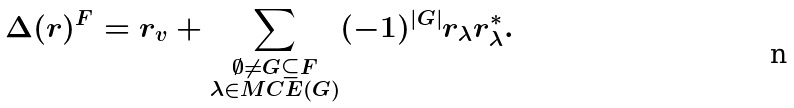<formula> <loc_0><loc_0><loc_500><loc_500>\Delta ( r ) ^ { F } = r _ { v } + \sum _ { \substack { \emptyset \neq G \subseteq F \\ \lambda \in M C E ( G ) } } ( - 1 ) ^ { | G | } r _ { \lambda } r _ { \lambda } ^ { * } .</formula> 